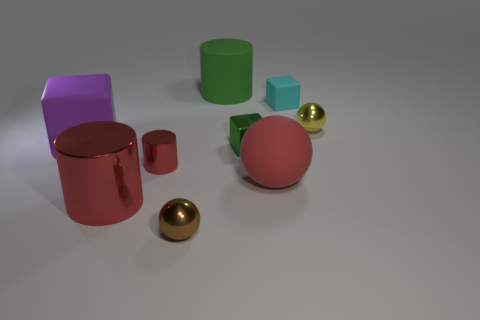What number of things are either large gray rubber spheres or shiny things?
Provide a short and direct response. 5. Does the green cylinder have the same size as the matte cube that is to the right of the purple matte cube?
Offer a very short reply. No. What number of other objects are the same material as the red ball?
Give a very brief answer. 3. What number of things are objects behind the small shiny cylinder or shiny spheres behind the large purple cube?
Make the answer very short. 5. There is a brown object that is the same shape as the small yellow metal object; what is it made of?
Provide a short and direct response. Metal. Are there any small brown rubber blocks?
Your answer should be compact. No. What size is the object that is to the right of the large red cylinder and to the left of the brown thing?
Keep it short and to the point. Small. There is a small brown thing; what shape is it?
Your answer should be compact. Sphere. Are there any large red metal things that are to the left of the shiny cylinder that is to the left of the tiny metallic cylinder?
Offer a terse response. No. What material is the brown thing that is the same size as the green metal block?
Offer a very short reply. Metal. 